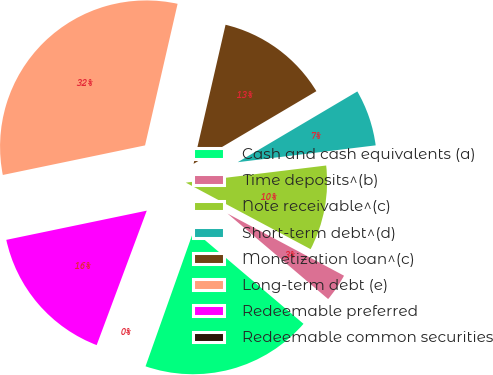Convert chart to OTSL. <chart><loc_0><loc_0><loc_500><loc_500><pie_chart><fcel>Cash and cash equivalents (a)<fcel>Time deposits^(b)<fcel>Note receivable^(c)<fcel>Short-term debt^(d)<fcel>Monetization loan^(c)<fcel>Long-term debt (e)<fcel>Redeemable preferred<fcel>Redeemable common securities<nl><fcel>19.22%<fcel>3.41%<fcel>9.73%<fcel>6.57%<fcel>12.9%<fcel>31.86%<fcel>16.06%<fcel>0.25%<nl></chart> 